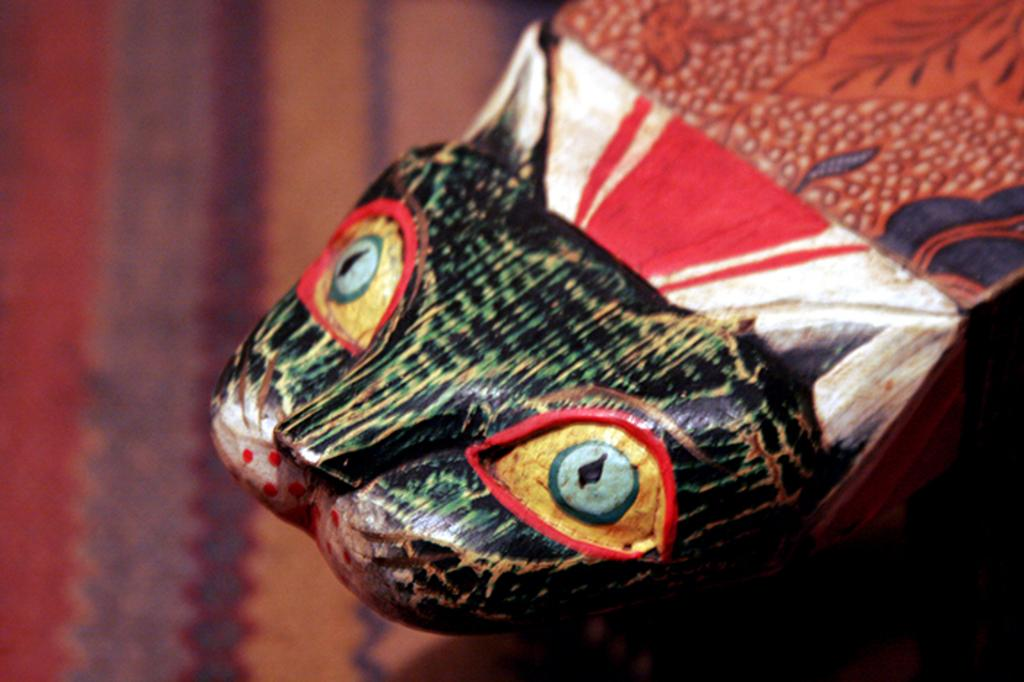What is the main subject of the image? There is an object that looks like a fish in the image. What can be seen beneath the fish in the image? The ground is visible in the image. How many spiders are crawling on the fish in the image? There are no spiders present in the image; it features an object that looks like a fish and the ground. What type of note is attached to the fish in the image? There is no note attached to the fish in the image. 